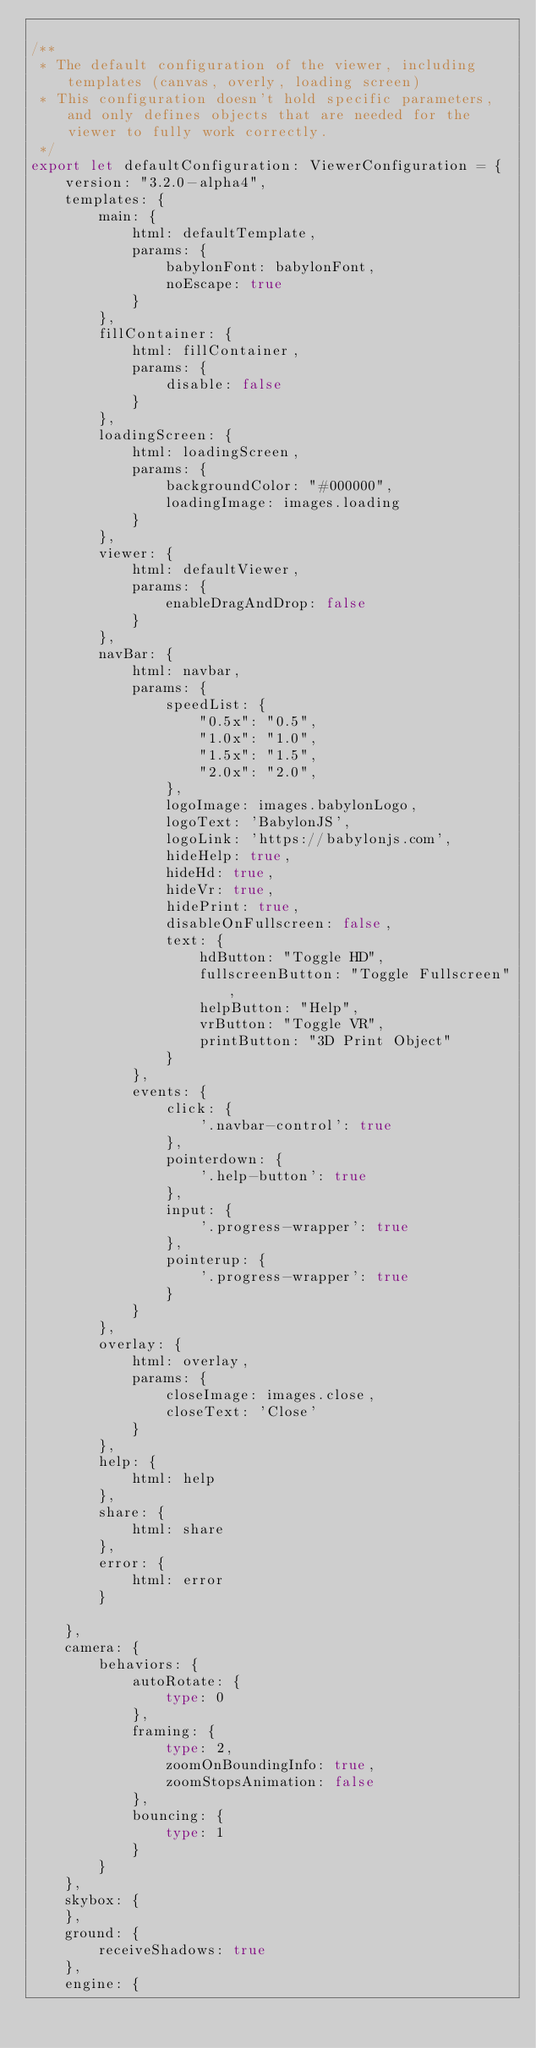Convert code to text. <code><loc_0><loc_0><loc_500><loc_500><_TypeScript_>
/**
 * The default configuration of the viewer, including templates (canvas, overly, loading screen)
 * This configuration doesn't hold specific parameters, and only defines objects that are needed for the viewer to fully work correctly.
 */
export let defaultConfiguration: ViewerConfiguration = {
    version: "3.2.0-alpha4",
    templates: {
        main: {
            html: defaultTemplate,
            params: {
                babylonFont: babylonFont,
                noEscape: true
            }
        },
        fillContainer: {
            html: fillContainer,
            params: {
                disable: false
            }
        },
        loadingScreen: {
            html: loadingScreen,
            params: {
                backgroundColor: "#000000",
                loadingImage: images.loading
            }
        },
        viewer: {
            html: defaultViewer,
            params: {
                enableDragAndDrop: false
            }
        },
        navBar: {
            html: navbar,
            params: {
                speedList: {
                    "0.5x": "0.5",
                    "1.0x": "1.0",
                    "1.5x": "1.5",
                    "2.0x": "2.0",
                },
                logoImage: images.babylonLogo,
                logoText: 'BabylonJS',
                logoLink: 'https://babylonjs.com',
                hideHelp: true,
                hideHd: true,
                hideVr: true,
                hidePrint: true,
                disableOnFullscreen: false,
                text: {
                    hdButton: "Toggle HD",
                    fullscreenButton: "Toggle Fullscreen",
                    helpButton: "Help",
                    vrButton: "Toggle VR",
                    printButton: "3D Print Object"
                }
            },
            events: {
                click: {
                    '.navbar-control': true
                },
                pointerdown: {
                    '.help-button': true
                },
                input: {
                    '.progress-wrapper': true
                },
                pointerup: {
                    '.progress-wrapper': true
                }
            }
        },
        overlay: {
            html: overlay,
            params: {
                closeImage: images.close,
                closeText: 'Close'
            }
        },
        help: {
            html: help
        },
        share: {
            html: share
        },
        error: {
            html: error
        }

    },
    camera: {
        behaviors: {
            autoRotate: {
                type: 0
            },
            framing: {
                type: 2,
                zoomOnBoundingInfo: true,
                zoomStopsAnimation: false
            },
            bouncing: {
                type: 1
            }
        }
    },
    skybox: {
    },
    ground: {
        receiveShadows: true
    },
    engine: {</code> 